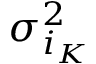Convert formula to latex. <formula><loc_0><loc_0><loc_500><loc_500>\sigma _ { i _ { K } } ^ { 2 }</formula> 